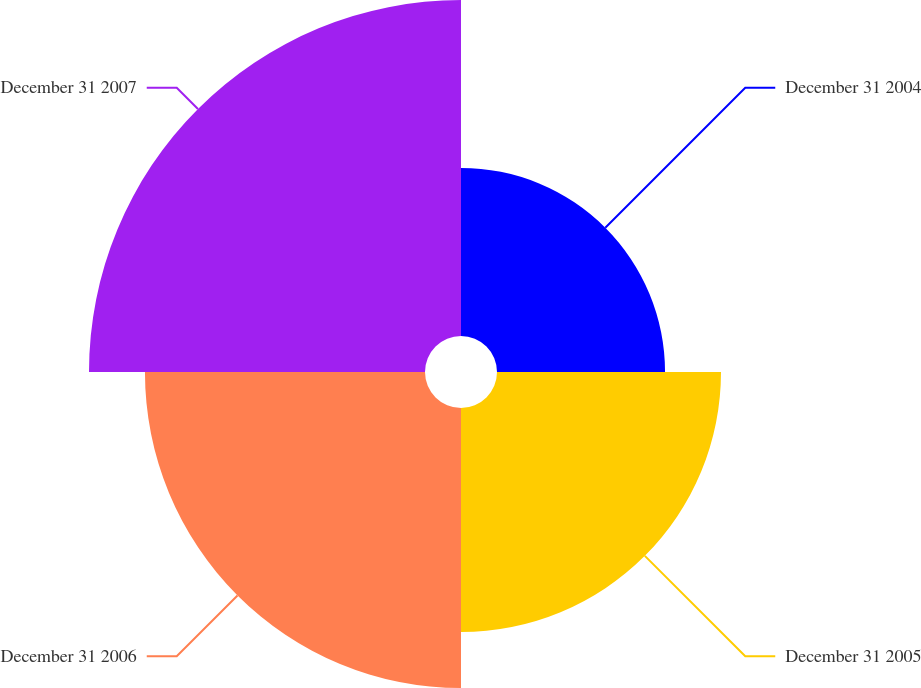Convert chart to OTSL. <chart><loc_0><loc_0><loc_500><loc_500><pie_chart><fcel>December 31 2004<fcel>December 31 2005<fcel>December 31 2006<fcel>December 31 2007<nl><fcel>16.67%<fcel>22.22%<fcel>27.78%<fcel>33.33%<nl></chart> 